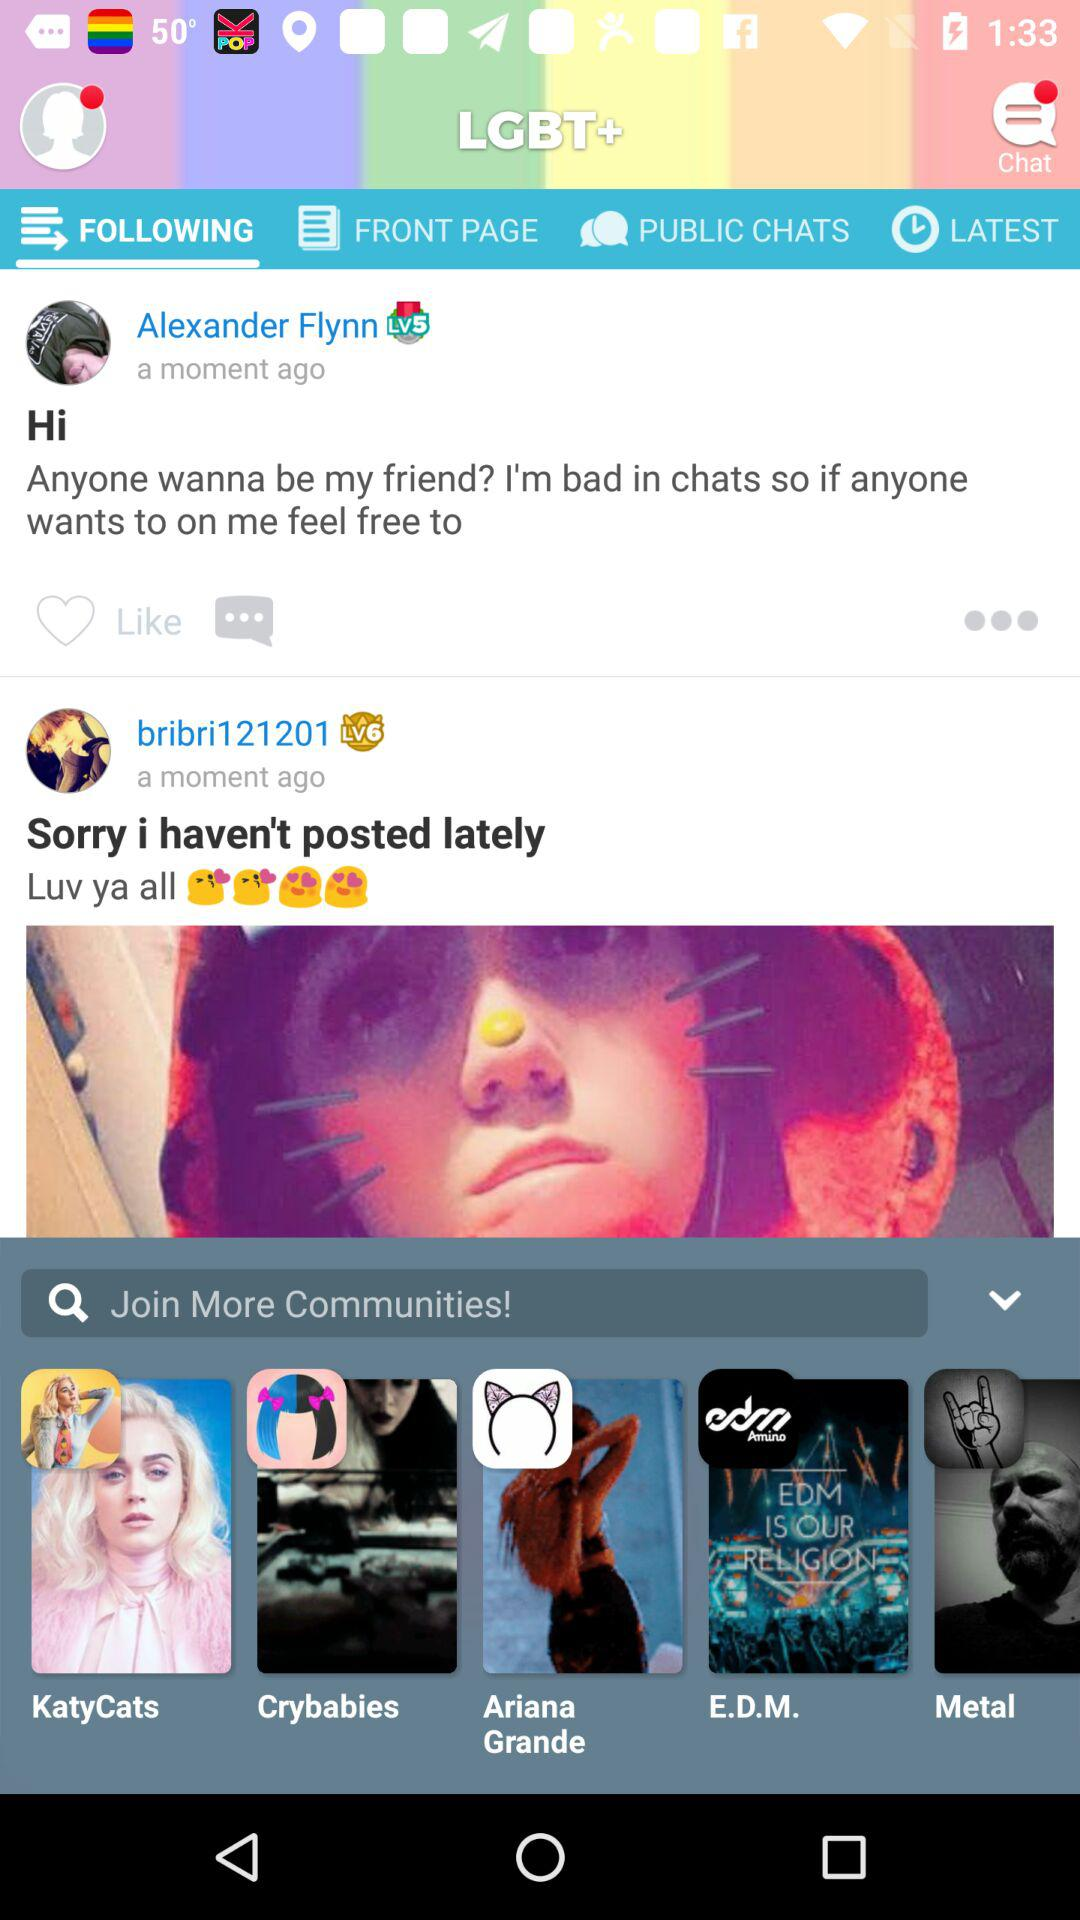When was the post posted by Alexander Flynn? The post was posted a moment ago. 